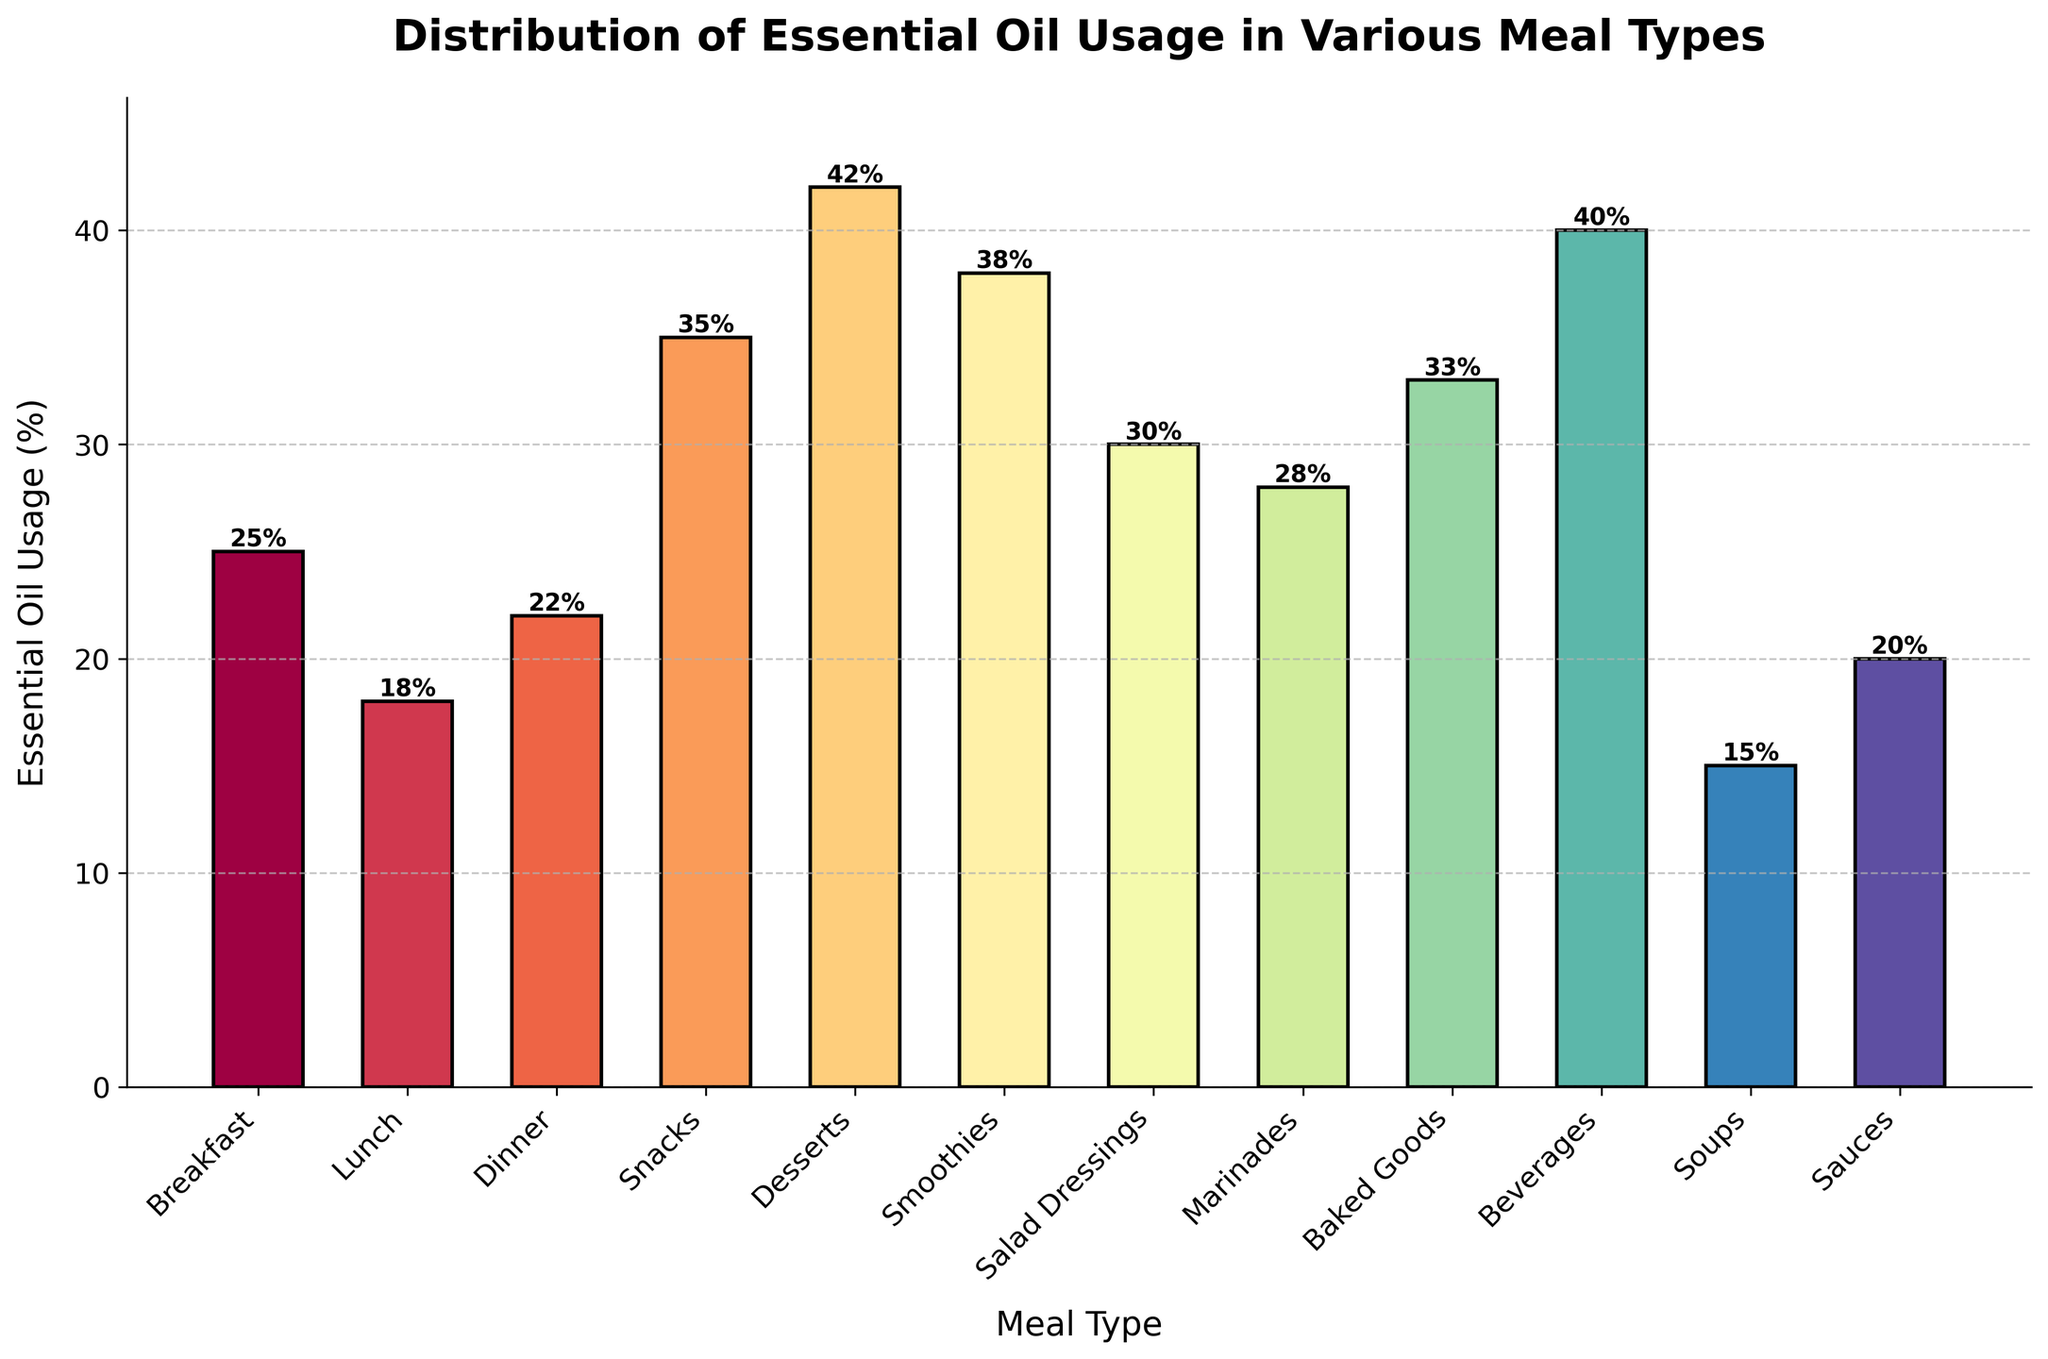Which meal type has the highest essential oil usage? The bar chart depicts the essential oil usage percentage for different meal types. By identifying the tallest bar, we find that the "Desserts" category has the highest essential oil usage at 42%.
Answer: Desserts Which meal type has the lowest essential oil usage? The bar chart shows the essential oil usage percentages for various meal types. The shortest bar represents the "Soups" category with a 15% usage rate.
Answer: Soups What is the difference in essential oil usage between Beverages and Sauces? The bar chart indicates that essential oil usage for Beverages is 40% and for Sauces is 20%. Subtracting the two values gives the difference: 40% - 20% = 20%.
Answer: 20% What is the average essential oil usage of Baked Goods, Beverages, and Smoothies? The essential oil usage for Baked Goods is 33%, Beverages is 40%, and Smoothies is 38%. Summing these values (33 + 40 + 38) equals 111%. Dividing by the number of categories (3) gives the average: 111 / 3 = 37%.
Answer: 37% Is essential oil usage higher in Marinades or Salads? From the bar chart, Marinades have an essential oil usage of 28% while Salad Dressings have a usage of 30%. Comparing these two, Salad Dressings have a higher usage.
Answer: Salad Dressings Which meal type utilizes essential oils more, Lunch or Dinner? According to the bar chart, the essential oil usage for Lunch is 18% and for Dinner is 22%. Dinner has a higher essential oil usage compared to Lunch.
Answer: Dinner What is the total essential oil usage percentage for Breakfast, Lunch, and Dinner combined? The essential oil usage for Breakfast is 25%, Lunch is 18%, and Dinner is 22%. Adding these values together gives: 25 + 18 + 22 = 65%.
Answer: 65% How many meal types have essential oil usage greater than 25%? From the bar chart, the meal types with essential oil usage over 25% are Breakfast (25%), Snacks (35%), Desserts (42%), Smoothies (38%), Salad Dressings (30%), Marinades (28%), Baked Goods (33%), and Beverages (40%). There are 8 such meal types.
Answer: 8 Which category has a closer essential oil usage percentage to Sauces, Lunch or Soups? The essential oil usage for Sauces is 20%, for Lunch is 18%, and for Soups is 15%. The difference between Sauces and Lunch is 2% (20 - 18 = 2), while for Soups it is 5% (20 - 15 = 5). Lunch is closer to Sauces in terms of essential oil usage.
Answer: Lunch 